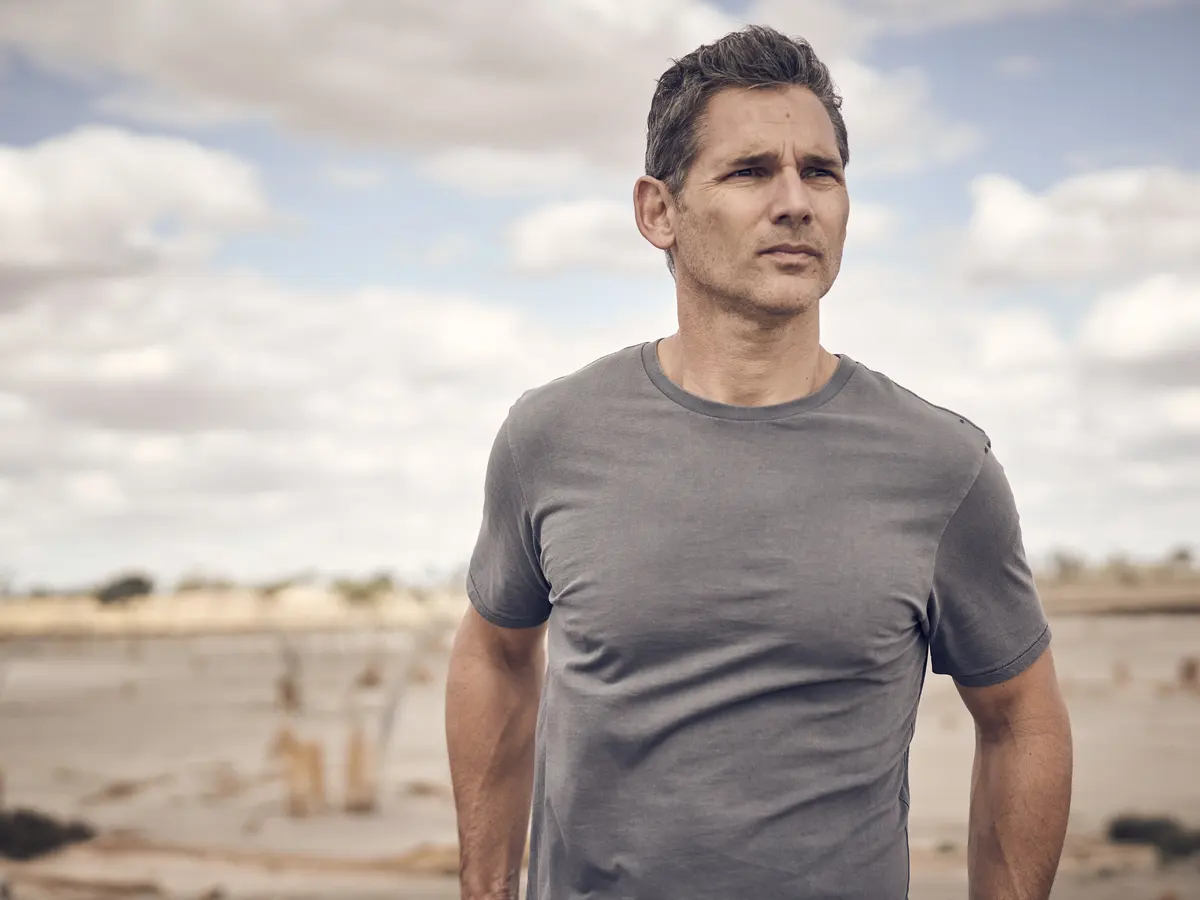Describe a possible future scenario for the man in the image after this moment of contemplation. After this moment of contemplation on the beach, the man might feel a renewed sense of purpose and clarity. Inspired by the tranquility of the setting, he decides to make significant changes in his life—perhaps reconnecting with loved ones, pursuing a long-held passion, or embarking on a new career path. This pivotal moment becomes a turning point, leading him to a more fulfilling and purposeful life. 